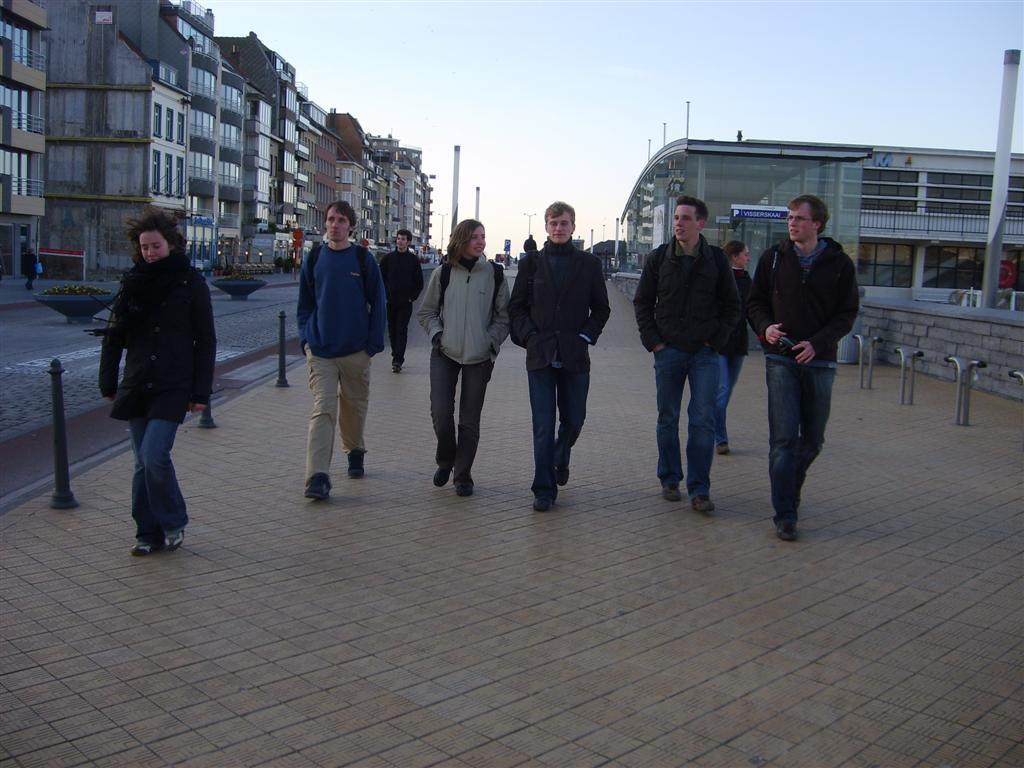What are the persons in the image doing? The persons in the image are walking. Where are they walking? They are walking on a footpath. What can be seen on the left side of the image? There are buildings on the left side of the image. What is visible in the background of the image? The background of the image includes buildings. What is the condition of the sky in the image? The sky is clear and visible at the top of the image. What type of print can be seen on the persons' clothes in the image? There is no information about the print on the persons' clothes in the image. What role are the persons playing in the image? The persons are not acting or playing any roles in the image; they are simply walking. 